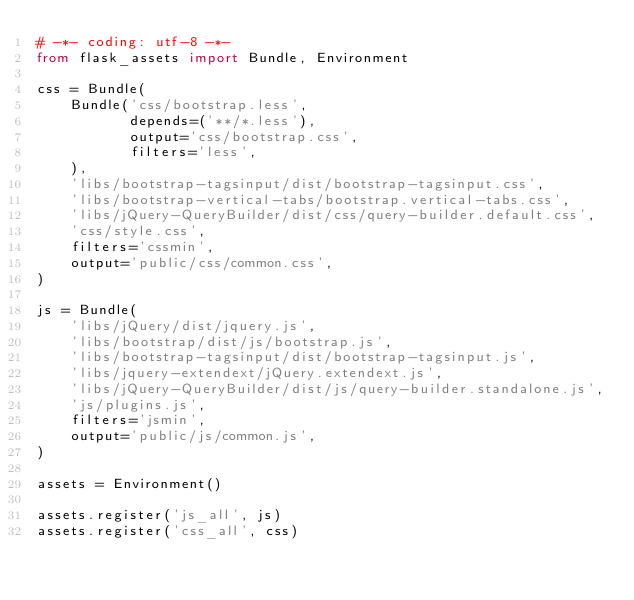<code> <loc_0><loc_0><loc_500><loc_500><_Python_># -*- coding: utf-8 -*-
from flask_assets import Bundle, Environment

css = Bundle(
    Bundle('css/bootstrap.less',
           depends=('**/*.less'),
           output='css/bootstrap.css',
           filters='less',
    ),
    'libs/bootstrap-tagsinput/dist/bootstrap-tagsinput.css',
    'libs/bootstrap-vertical-tabs/bootstrap.vertical-tabs.css',
    'libs/jQuery-QueryBuilder/dist/css/query-builder.default.css',
    'css/style.css',
    filters='cssmin',
    output='public/css/common.css',
)

js = Bundle(
    'libs/jQuery/dist/jquery.js',
    'libs/bootstrap/dist/js/bootstrap.js',
    'libs/bootstrap-tagsinput/dist/bootstrap-tagsinput.js',
    'libs/jquery-extendext/jQuery.extendext.js',
    'libs/jQuery-QueryBuilder/dist/js/query-builder.standalone.js',
    'js/plugins.js',
    filters='jsmin',
    output='public/js/common.js',
)

assets = Environment()

assets.register('js_all', js)
assets.register('css_all', css)
</code> 